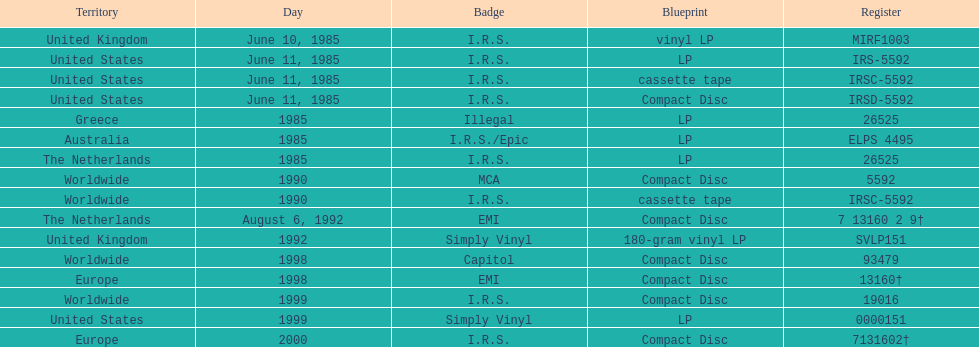In how many nations was the record launched prior to 1990? 5. 